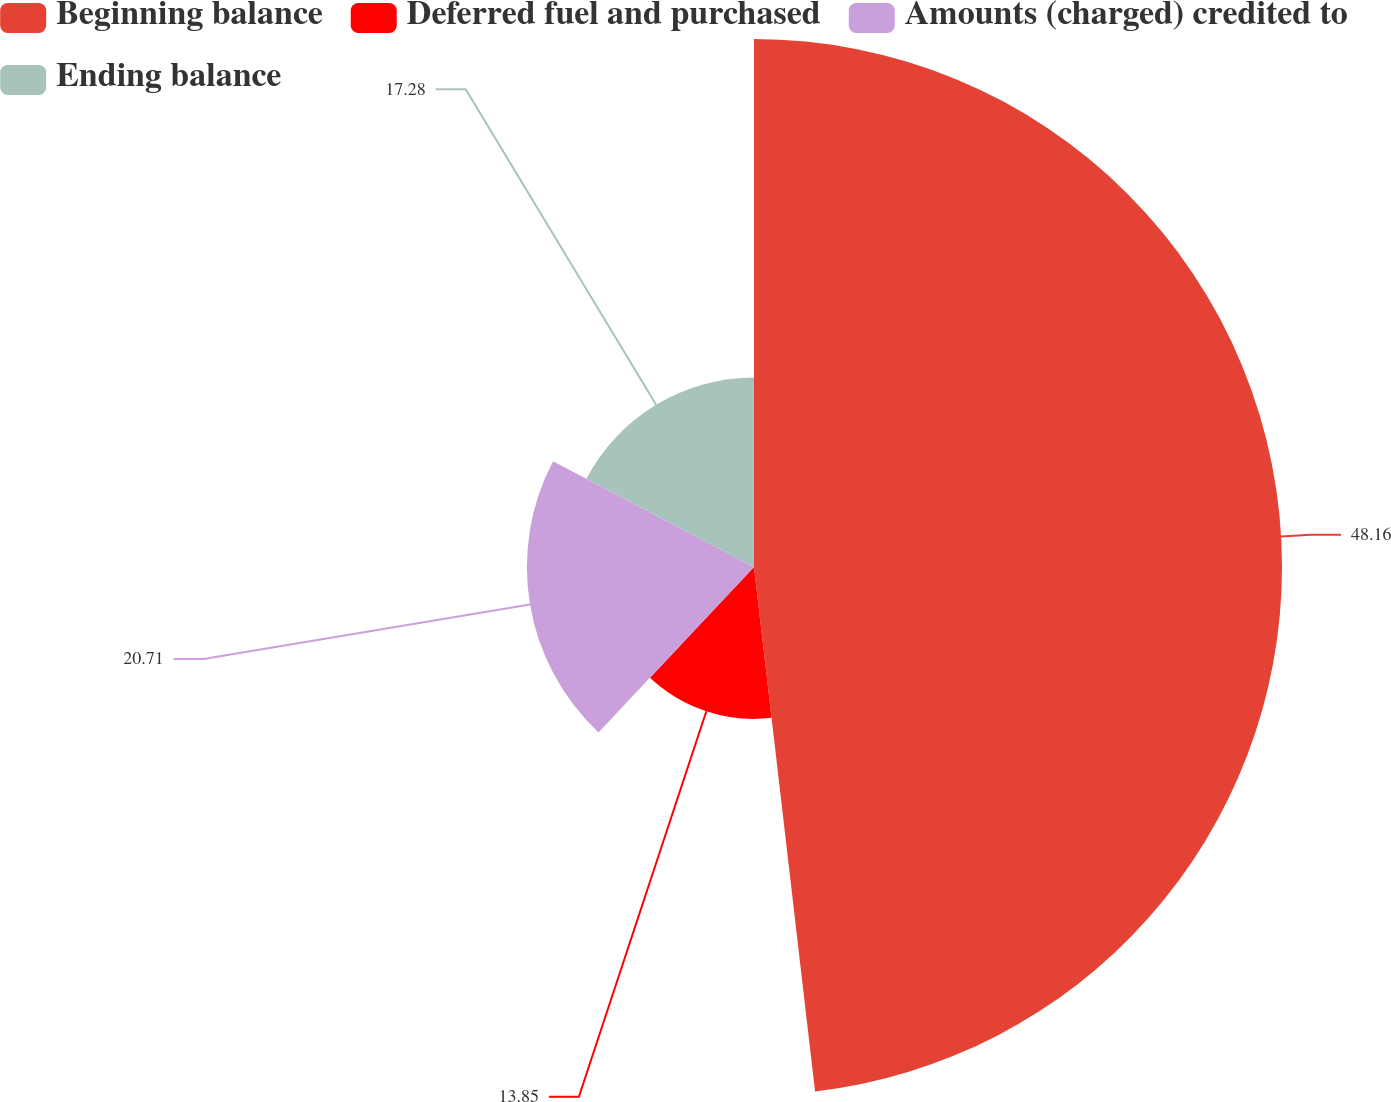Convert chart. <chart><loc_0><loc_0><loc_500><loc_500><pie_chart><fcel>Beginning balance<fcel>Deferred fuel and purchased<fcel>Amounts (charged) credited to<fcel>Ending balance<nl><fcel>48.15%<fcel>13.85%<fcel>20.71%<fcel>17.28%<nl></chart> 